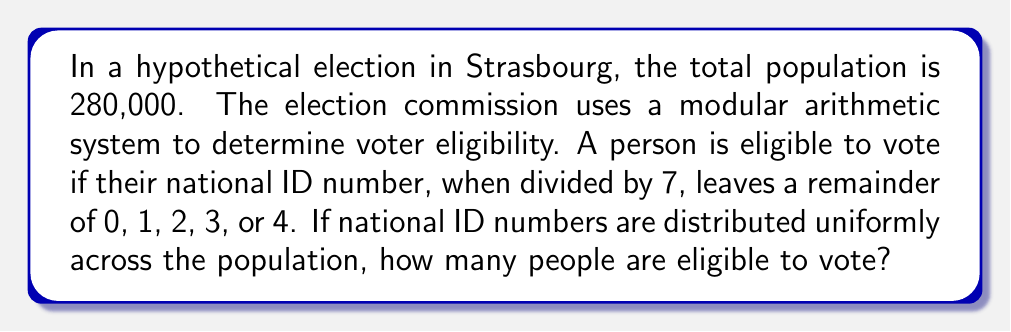Can you solve this math problem? Let's approach this step-by-step:

1) First, we need to understand what the question is asking. We're looking for the number of people whose ID numbers satisfy the condition: $ID \equiv 0, 1, 2, 3,$ or $4 \pmod{7}$

2) This means that out of every 7 consecutive ID numbers, 5 will be eligible (those with remainders 0, 1, 2, 3, and 4).

3) We can express this as a fraction: $\frac{5}{7}$ of the population will be eligible.

4) Now, let's calculate:

   $$\text{Eligible voters} = \text{Total population} \times \frac{\text{Eligible remainders}}{\text{Total possible remainders}}$$

   $$\text{Eligible voters} = 280,000 \times \frac{5}{7}$$

5) Let's perform this calculation:

   $$\text{Eligible voters} = \frac{280,000 \times 5}{7} = \frac{1,400,000}{7} = 200,000$$

Therefore, 200,000 people are eligible to vote in this hypothetical election.
Answer: 200,000 